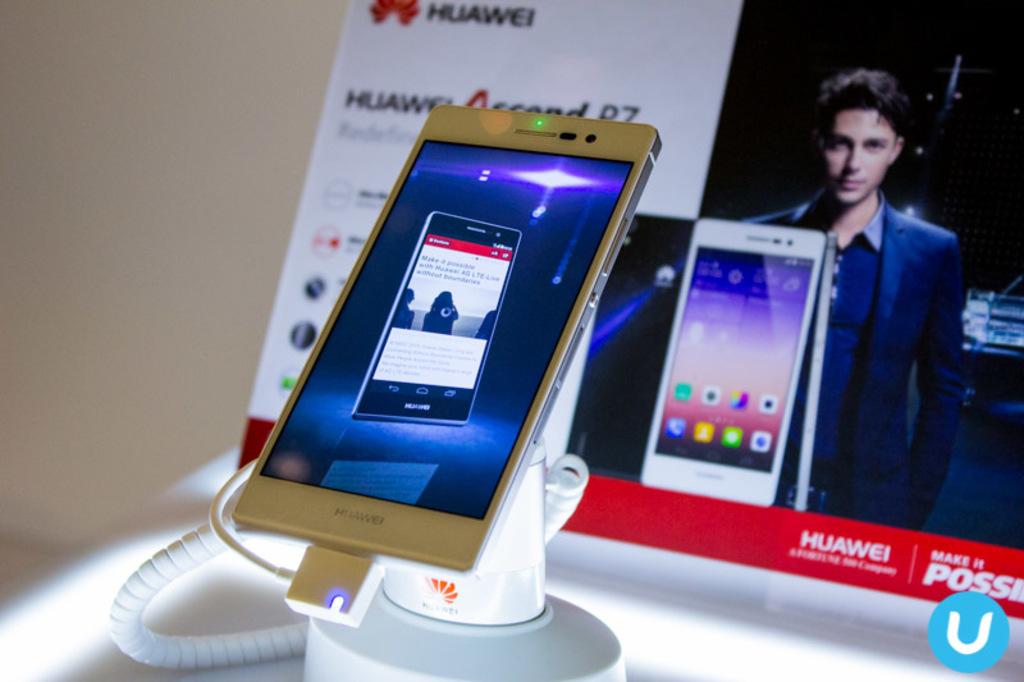What is the brand of the mobile in this image?
Ensure brevity in your answer.  Huawei. 